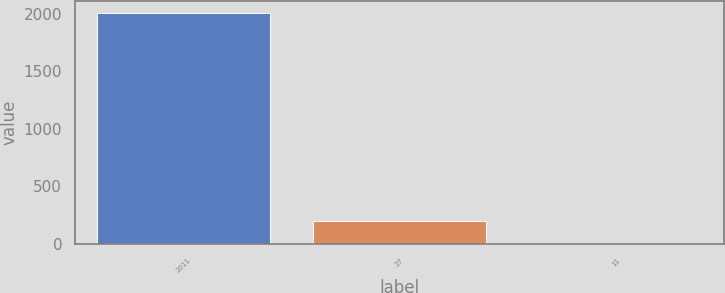<chart> <loc_0><loc_0><loc_500><loc_500><bar_chart><fcel>2011<fcel>27<fcel>11<nl><fcel>2010<fcel>201.99<fcel>1.1<nl></chart> 